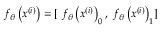Convert formula to latex. <formula><loc_0><loc_0><loc_500><loc_500>f _ { \theta } \left ( x ^ { ( i ) } \right ) = [ \ f _ { \theta } \left ( x ^ { \left ( i \right ) } \right ) _ { 0 } , \ f _ { \theta } \left ( x ^ { \left ( i \right ) } \right ) _ { 1 } ]</formula> 